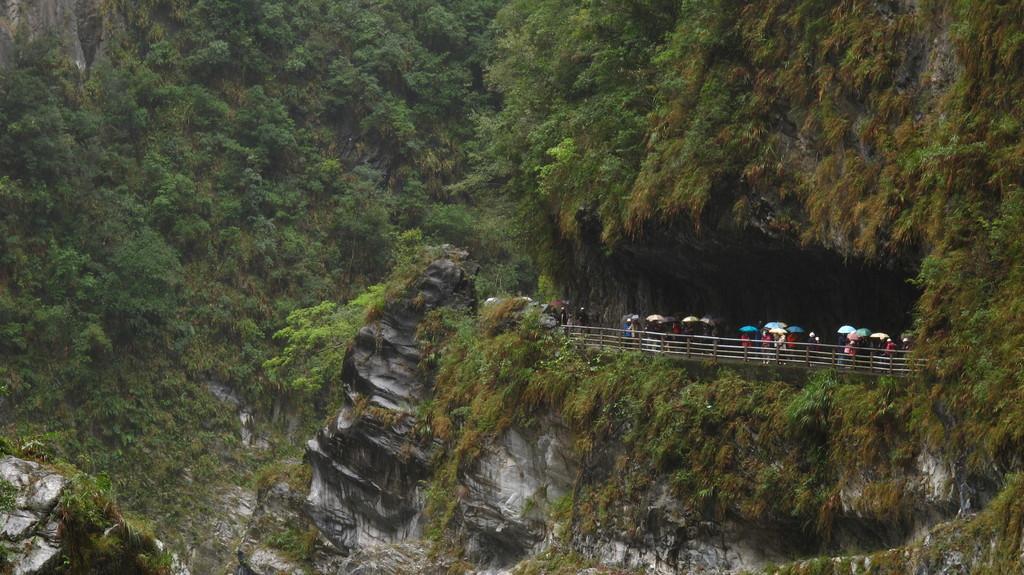Could you give a brief overview of what you see in this image? In this picture we observe a road which is under the cave and in the background we observe a trees and grasslands all over the place. 